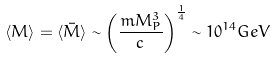<formula> <loc_0><loc_0><loc_500><loc_500>\langle M \rangle = \langle \bar { M } \rangle \sim \left ( \frac { m M _ { P } ^ { 3 } } { c } \right ) ^ { \frac { 1 } { 4 } } \sim 1 0 ^ { 1 4 } G e V</formula> 